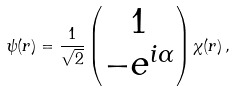Convert formula to latex. <formula><loc_0><loc_0><loc_500><loc_500>\psi ( { r } ) = \frac { 1 } { \sqrt { 2 } } \left ( \begin{matrix} 1 \\ - e ^ { i \alpha } \end{matrix} \right ) \chi ( r ) \, ,</formula> 